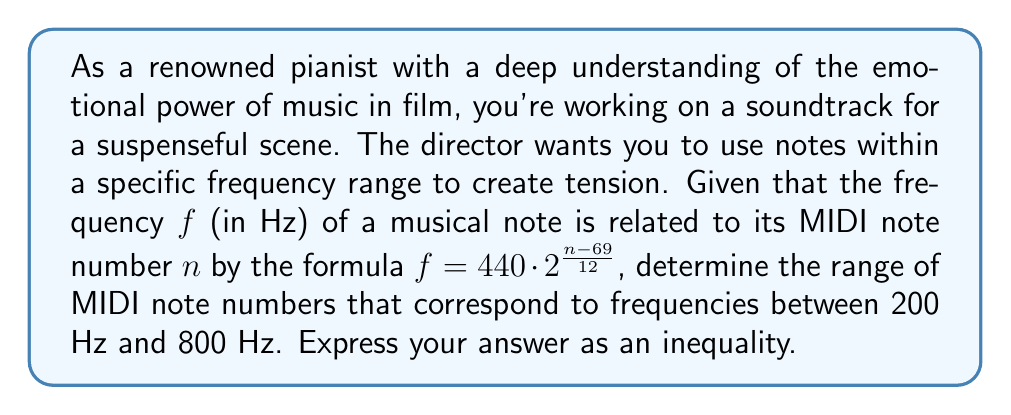Solve this math problem. Let's approach this step-by-step:

1) We start with the given formula: $f = 440 \cdot 2^{\frac{n - 69}{12}}$

2) We want to find the range of $n$ where $200 \leq f \leq 800$

3) Let's solve the inequality:

   $200 \leq 440 \cdot 2^{\frac{n - 69}{12}} \leq 800$

4) Divide all parts by 440:

   $\frac{5}{11} \leq 2^{\frac{n - 69}{12}} \leq \frac{20}{11}$

5) Take the logarithm (base 2) of all parts:

   $\log_2(\frac{5}{11}) \leq \frac{n - 69}{12} \leq \log_2(\frac{20}{11})$

6) Multiply all parts by 12:

   $12\log_2(\frac{5}{11}) \leq n - 69 \leq 12\log_2(\frac{20}{11})$

7) Add 69 to all parts:

   $12\log_2(\frac{5}{11}) + 69 \leq n \leq 12\log_2(\frac{20}{11}) + 69$

8) Calculate the values:

   $12\log_2(\frac{5}{11}) + 69 \approx 55.80$
   $12\log_2(\frac{20}{11}) + 69 \approx 81.02$

9) Since $n$ represents MIDI note numbers, which are integers, we round up the lower bound and round down the upper bound:

   $56 \leq n \leq 81$
Answer: $56 \leq n \leq 81$, where $n$ is the MIDI note number. 